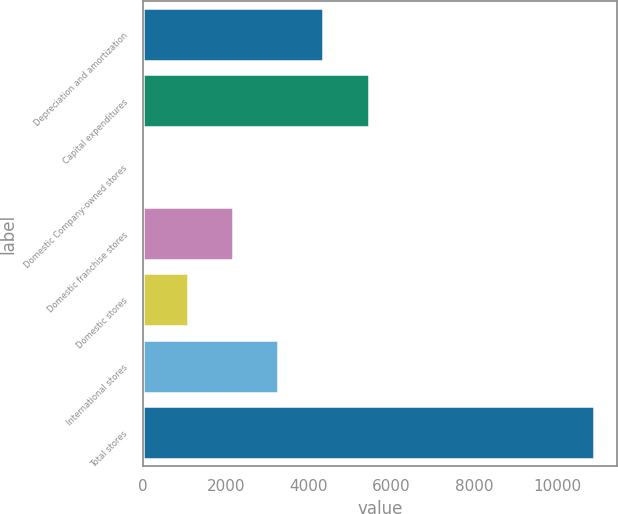<chart> <loc_0><loc_0><loc_500><loc_500><bar_chart><fcel>Depreciation and amortization<fcel>Capital expenditures<fcel>Domestic Company-owned stores<fcel>Domestic franchise stores<fcel>Domestic stores<fcel>International stores<fcel>Total stores<nl><fcel>4356.74<fcel>5444.95<fcel>3.9<fcel>2180.32<fcel>1092.11<fcel>3268.53<fcel>10886<nl></chart> 